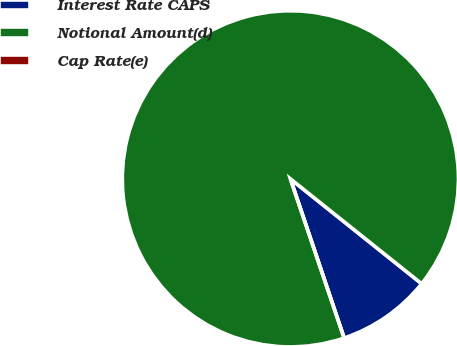<chart> <loc_0><loc_0><loc_500><loc_500><pie_chart><fcel>Interest Rate CAPS<fcel>Notional Amount(d)<fcel>Cap Rate(e)<nl><fcel>9.09%<fcel>90.91%<fcel>0.0%<nl></chart> 